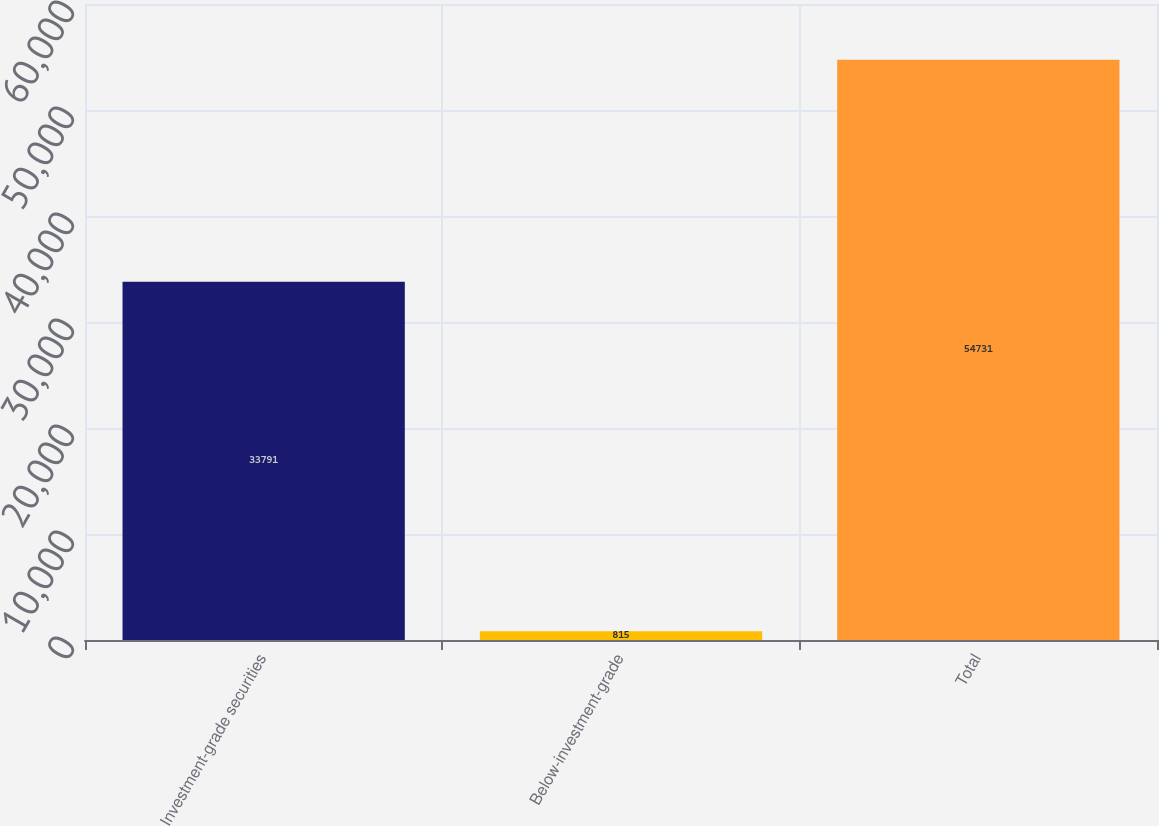Convert chart. <chart><loc_0><loc_0><loc_500><loc_500><bar_chart><fcel>Investment-grade securities<fcel>Below-investment-grade<fcel>Total<nl><fcel>33791<fcel>815<fcel>54731<nl></chart> 